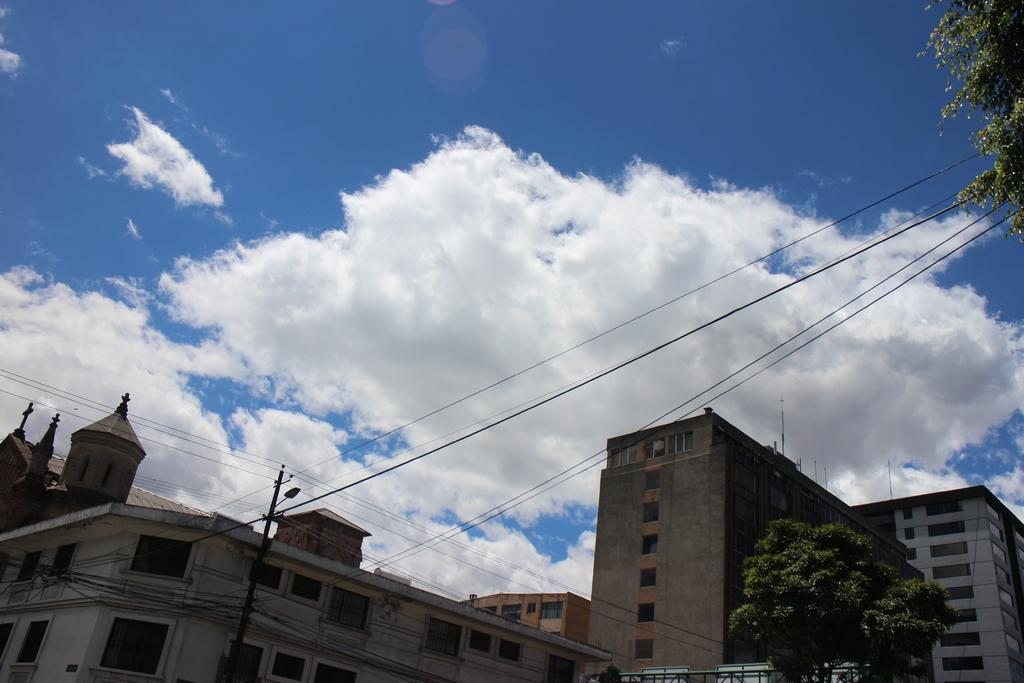What type of structures can be seen in the image? There are buildings in the image. What feature do the buildings have? The buildings have windows. What other objects are present in the image? There are trees, current-poles, wires, light poles, and boards attached to the poles. What is the color of the sky in the image? The sky is blue and white in color. Can you tell me the order of the birth of the clouds in the image? There are no clouds present in the image, so it is not possible to determine the order of their birth. 